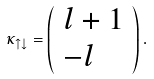Convert formula to latex. <formula><loc_0><loc_0><loc_500><loc_500>\kappa _ { \uparrow \downarrow } = \left ( \begin{array} { l l } l + 1 \\ - l \end{array} \right ) .</formula> 